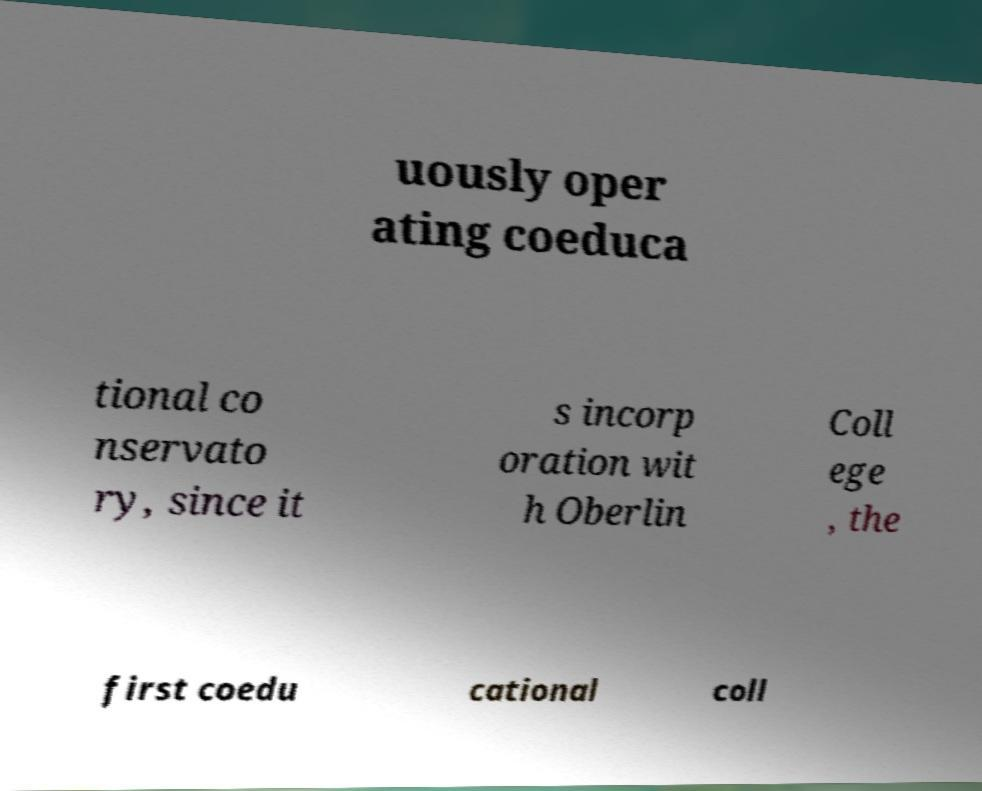Please identify and transcribe the text found in this image. uously oper ating coeduca tional co nservato ry, since it s incorp oration wit h Oberlin Coll ege , the first coedu cational coll 